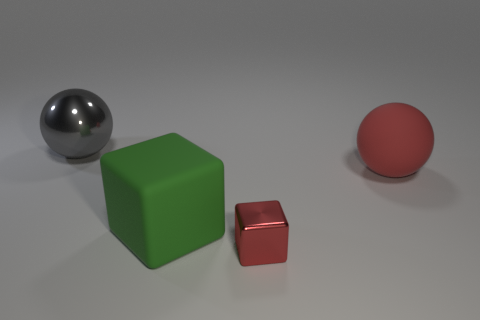Add 3 big gray spheres. How many objects exist? 7 Subtract all red blocks. How many blocks are left? 1 Subtract 2 blocks. How many blocks are left? 0 Subtract 0 brown cylinders. How many objects are left? 4 Subtract all brown spheres. Subtract all blue cylinders. How many spheres are left? 2 Subtract all small yellow rubber cylinders. Subtract all big matte spheres. How many objects are left? 3 Add 2 large green matte cubes. How many large green matte cubes are left? 3 Add 2 tiny purple metallic cylinders. How many tiny purple metallic cylinders exist? 2 